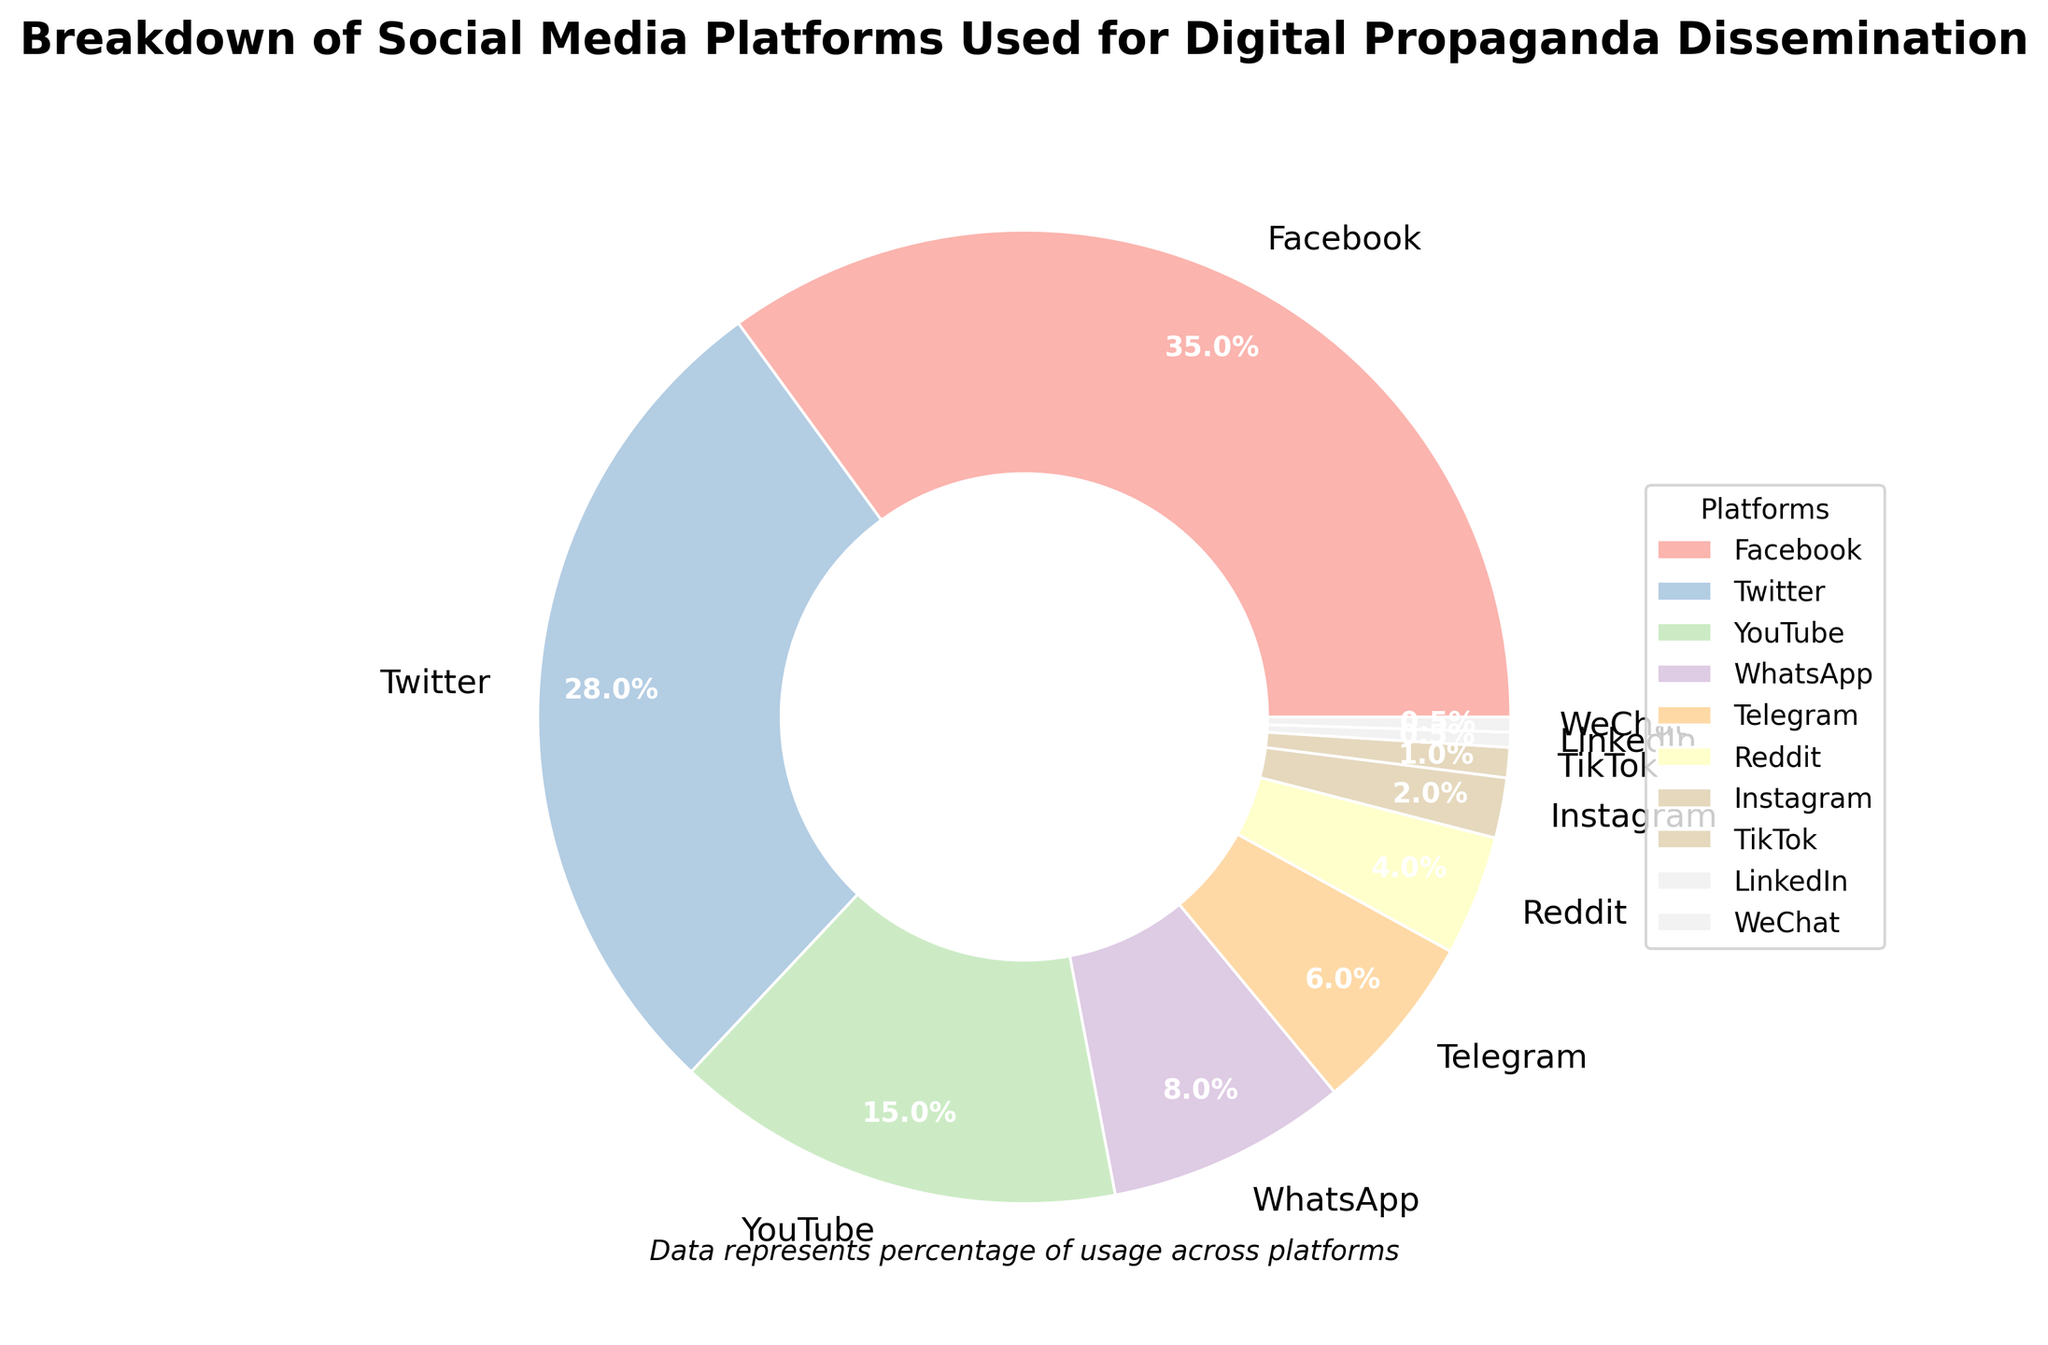What's the largest social media platform used for digital propaganda dissemination? The largest platform segment in the pie chart is represented by Facebook, which has the highest percentage usage for digital propaganda dissemination.
Answer: Facebook Which social media platform has the smallest percentage of usage for digital propaganda? The smallest segment in the pie chart represents LinkedIn and WeChat, each with a 0.5% usage for digital propaganda.
Answer: LinkedIn and WeChat What is the combined percentage for Facebook and Twitter? Facebook has a percentage of 35% and Twitter has a percentage of 28%. Adding these together, the combined percentage is 35 + 28 = 63%.
Answer: 63% How does YouTube's usage for digital propaganda compare to WhatsApp's? YouTube's segment shows a 15% usage while WhatsApp's segment displays an 8% usage. Therefore, YouTube has a higher usage compared to WhatsApp.
Answer: YouTube is higher Which three platforms combined account for more than half of the digital propaganda dissemination? The three segments with the highest percentages are Facebook (35%), Twitter (28%), and YouTube (15%). Adding them together: 35 + 28 + 15 = 78%, which is more than half.
Answer: Facebook, Twitter, and YouTube What percentage of digital propaganda dissemination is carried out by Telegram, Reddit, Instagram, and TikTok combined? Telegram has 6%, Reddit 4%, Instagram 2%, and TikTok 1%. Adding these percentages together: 6 + 4 + 2 + 1 = 13%.
Answer: 13% Which platform has twice the percentage usage compared to Telegram? Telegram is at 6%, so the platform with twice the usage would be 6% * 2 = 12%. No single platform matches this exactly, but Reddit (4%) combined with WhatsApp (8%) sums to 12%, which is twice the percentage of Telegram.
Answer: No single platform, but WhatsApp and Reddit combined Between Facebook, Twitter, and YouTube, which two platforms together account for the highest use? Facebook is at 35%, Twitter at 28%, and YouTube at 15%. Adding Facebook and Twitter results in 35 + 28 = 63%, which is higher than any other combination of two of these three platforms.
Answer: Facebook and Twitter How much more percentage does Twitter have in terms of usage for digital propaganda compared to Instagram? Twitter has 28%, and Instagram has 2%. Subtracting these values: 28 - 2 = 26%. So, Twitter has 26% more usage than Instagram.
Answer: 26% What is the percentage gap between the most and least used platforms? The most used platform is Facebook with 35%, and the least used platforms are LinkedIn and WeChat with 0.5%. Subtracting these: 35 - 0.5 = 34.5%.
Answer: 34.5% 